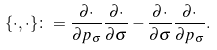Convert formula to latex. <formula><loc_0><loc_0><loc_500><loc_500>\{ \cdot , \cdot \} \colon = \frac { \partial \cdot } { \partial p _ { \sigma } } \frac { \partial \cdot } { \partial \sigma } - \frac { \partial \cdot } { \partial \sigma } \frac { \partial \cdot } { \partial p _ { \sigma } } .</formula> 